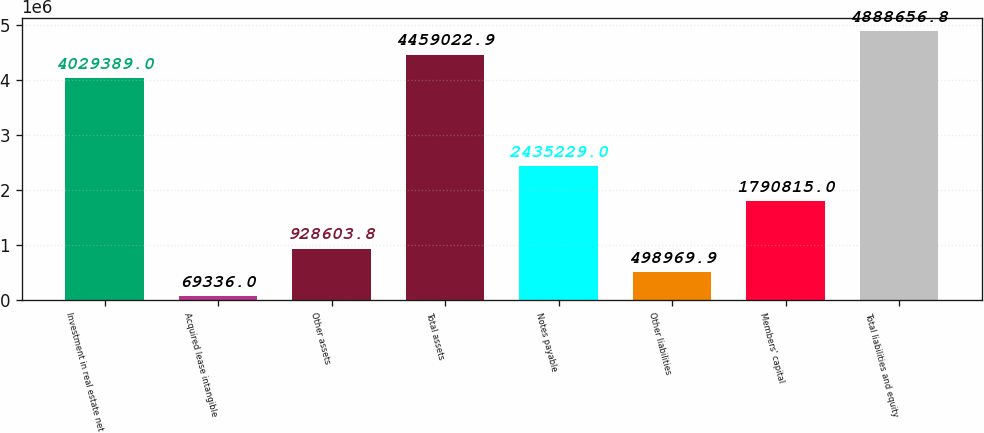Convert chart. <chart><loc_0><loc_0><loc_500><loc_500><bar_chart><fcel>Investment in real estate net<fcel>Acquired lease intangible<fcel>Other assets<fcel>Total assets<fcel>Notes payable<fcel>Other liabilities<fcel>Members' capital<fcel>Total liabilities and equity<nl><fcel>4.02939e+06<fcel>69336<fcel>928604<fcel>4.45902e+06<fcel>2.43523e+06<fcel>498970<fcel>1.79082e+06<fcel>4.88866e+06<nl></chart> 